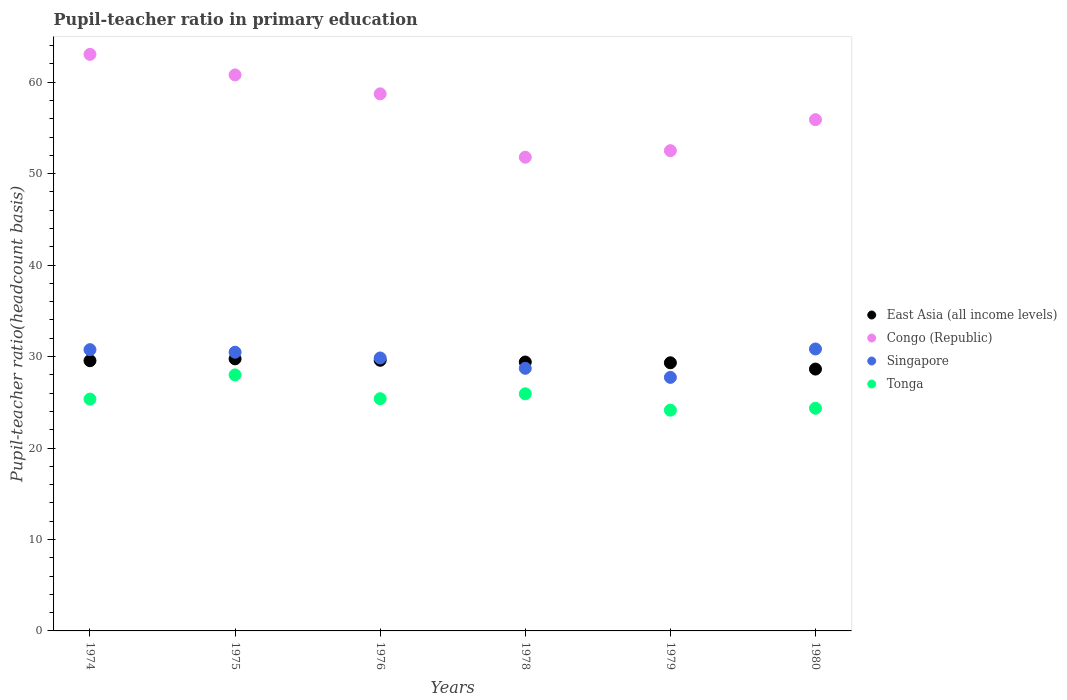How many different coloured dotlines are there?
Your response must be concise. 4. Is the number of dotlines equal to the number of legend labels?
Provide a succinct answer. Yes. What is the pupil-teacher ratio in primary education in Congo (Republic) in 1978?
Provide a short and direct response. 51.8. Across all years, what is the maximum pupil-teacher ratio in primary education in Tonga?
Keep it short and to the point. 27.99. Across all years, what is the minimum pupil-teacher ratio in primary education in Singapore?
Your answer should be very brief. 27.72. In which year was the pupil-teacher ratio in primary education in Tonga maximum?
Provide a short and direct response. 1975. In which year was the pupil-teacher ratio in primary education in Congo (Republic) minimum?
Your response must be concise. 1978. What is the total pupil-teacher ratio in primary education in Congo (Republic) in the graph?
Offer a very short reply. 342.76. What is the difference between the pupil-teacher ratio in primary education in East Asia (all income levels) in 1974 and that in 1976?
Keep it short and to the point. -0.05. What is the difference between the pupil-teacher ratio in primary education in Tonga in 1978 and the pupil-teacher ratio in primary education in Congo (Republic) in 1976?
Your answer should be very brief. -32.8. What is the average pupil-teacher ratio in primary education in Tonga per year?
Ensure brevity in your answer.  25.52. In the year 1975, what is the difference between the pupil-teacher ratio in primary education in East Asia (all income levels) and pupil-teacher ratio in primary education in Singapore?
Provide a short and direct response. -0.73. In how many years, is the pupil-teacher ratio in primary education in Congo (Republic) greater than 12?
Keep it short and to the point. 6. What is the ratio of the pupil-teacher ratio in primary education in East Asia (all income levels) in 1975 to that in 1979?
Make the answer very short. 1.01. Is the pupil-teacher ratio in primary education in Tonga in 1975 less than that in 1980?
Ensure brevity in your answer.  No. What is the difference between the highest and the second highest pupil-teacher ratio in primary education in Tonga?
Your answer should be very brief. 2.07. What is the difference between the highest and the lowest pupil-teacher ratio in primary education in Singapore?
Your response must be concise. 3.11. In how many years, is the pupil-teacher ratio in primary education in East Asia (all income levels) greater than the average pupil-teacher ratio in primary education in East Asia (all income levels) taken over all years?
Keep it short and to the point. 4. Is the sum of the pupil-teacher ratio in primary education in East Asia (all income levels) in 1975 and 1978 greater than the maximum pupil-teacher ratio in primary education in Singapore across all years?
Provide a short and direct response. Yes. Is it the case that in every year, the sum of the pupil-teacher ratio in primary education in East Asia (all income levels) and pupil-teacher ratio in primary education in Singapore  is greater than the sum of pupil-teacher ratio in primary education in Congo (Republic) and pupil-teacher ratio in primary education in Tonga?
Provide a succinct answer. No. Does the pupil-teacher ratio in primary education in Congo (Republic) monotonically increase over the years?
Provide a short and direct response. No. Is the pupil-teacher ratio in primary education in Congo (Republic) strictly greater than the pupil-teacher ratio in primary education in Tonga over the years?
Provide a short and direct response. Yes. What is the difference between two consecutive major ticks on the Y-axis?
Offer a very short reply. 10. Are the values on the major ticks of Y-axis written in scientific E-notation?
Make the answer very short. No. Does the graph contain any zero values?
Provide a short and direct response. No. Does the graph contain grids?
Your answer should be very brief. No. Where does the legend appear in the graph?
Give a very brief answer. Center right. How are the legend labels stacked?
Provide a succinct answer. Vertical. What is the title of the graph?
Offer a terse response. Pupil-teacher ratio in primary education. Does "Hong Kong" appear as one of the legend labels in the graph?
Make the answer very short. No. What is the label or title of the X-axis?
Your answer should be very brief. Years. What is the label or title of the Y-axis?
Ensure brevity in your answer.  Pupil-teacher ratio(headcount basis). What is the Pupil-teacher ratio(headcount basis) in East Asia (all income levels) in 1974?
Provide a succinct answer. 29.54. What is the Pupil-teacher ratio(headcount basis) of Congo (Republic) in 1974?
Offer a very short reply. 63.04. What is the Pupil-teacher ratio(headcount basis) in Singapore in 1974?
Provide a short and direct response. 30.75. What is the Pupil-teacher ratio(headcount basis) in Tonga in 1974?
Your response must be concise. 25.35. What is the Pupil-teacher ratio(headcount basis) in East Asia (all income levels) in 1975?
Make the answer very short. 29.75. What is the Pupil-teacher ratio(headcount basis) of Congo (Republic) in 1975?
Offer a very short reply. 60.79. What is the Pupil-teacher ratio(headcount basis) of Singapore in 1975?
Provide a succinct answer. 30.47. What is the Pupil-teacher ratio(headcount basis) in Tonga in 1975?
Keep it short and to the point. 27.99. What is the Pupil-teacher ratio(headcount basis) in East Asia (all income levels) in 1976?
Your response must be concise. 29.59. What is the Pupil-teacher ratio(headcount basis) in Congo (Republic) in 1976?
Your answer should be very brief. 58.72. What is the Pupil-teacher ratio(headcount basis) of Singapore in 1976?
Keep it short and to the point. 29.84. What is the Pupil-teacher ratio(headcount basis) of Tonga in 1976?
Provide a succinct answer. 25.39. What is the Pupil-teacher ratio(headcount basis) of East Asia (all income levels) in 1978?
Your answer should be very brief. 29.4. What is the Pupil-teacher ratio(headcount basis) of Congo (Republic) in 1978?
Ensure brevity in your answer.  51.8. What is the Pupil-teacher ratio(headcount basis) in Singapore in 1978?
Provide a short and direct response. 28.71. What is the Pupil-teacher ratio(headcount basis) in Tonga in 1978?
Provide a short and direct response. 25.93. What is the Pupil-teacher ratio(headcount basis) of East Asia (all income levels) in 1979?
Make the answer very short. 29.32. What is the Pupil-teacher ratio(headcount basis) in Congo (Republic) in 1979?
Offer a very short reply. 52.51. What is the Pupil-teacher ratio(headcount basis) of Singapore in 1979?
Offer a very short reply. 27.72. What is the Pupil-teacher ratio(headcount basis) of Tonga in 1979?
Provide a short and direct response. 24.14. What is the Pupil-teacher ratio(headcount basis) of East Asia (all income levels) in 1980?
Provide a succinct answer. 28.63. What is the Pupil-teacher ratio(headcount basis) of Congo (Republic) in 1980?
Your answer should be very brief. 55.9. What is the Pupil-teacher ratio(headcount basis) of Singapore in 1980?
Offer a terse response. 30.83. What is the Pupil-teacher ratio(headcount basis) in Tonga in 1980?
Give a very brief answer. 24.34. Across all years, what is the maximum Pupil-teacher ratio(headcount basis) of East Asia (all income levels)?
Your response must be concise. 29.75. Across all years, what is the maximum Pupil-teacher ratio(headcount basis) in Congo (Republic)?
Provide a short and direct response. 63.04. Across all years, what is the maximum Pupil-teacher ratio(headcount basis) of Singapore?
Keep it short and to the point. 30.83. Across all years, what is the maximum Pupil-teacher ratio(headcount basis) in Tonga?
Offer a terse response. 27.99. Across all years, what is the minimum Pupil-teacher ratio(headcount basis) of East Asia (all income levels)?
Provide a short and direct response. 28.63. Across all years, what is the minimum Pupil-teacher ratio(headcount basis) in Congo (Republic)?
Your answer should be very brief. 51.8. Across all years, what is the minimum Pupil-teacher ratio(headcount basis) in Singapore?
Ensure brevity in your answer.  27.72. Across all years, what is the minimum Pupil-teacher ratio(headcount basis) in Tonga?
Keep it short and to the point. 24.14. What is the total Pupil-teacher ratio(headcount basis) in East Asia (all income levels) in the graph?
Ensure brevity in your answer.  176.23. What is the total Pupil-teacher ratio(headcount basis) of Congo (Republic) in the graph?
Offer a very short reply. 342.76. What is the total Pupil-teacher ratio(headcount basis) in Singapore in the graph?
Provide a short and direct response. 178.33. What is the total Pupil-teacher ratio(headcount basis) in Tonga in the graph?
Give a very brief answer. 153.14. What is the difference between the Pupil-teacher ratio(headcount basis) in East Asia (all income levels) in 1974 and that in 1975?
Make the answer very short. -0.2. What is the difference between the Pupil-teacher ratio(headcount basis) in Congo (Republic) in 1974 and that in 1975?
Your answer should be compact. 2.25. What is the difference between the Pupil-teacher ratio(headcount basis) of Singapore in 1974 and that in 1975?
Provide a short and direct response. 0.28. What is the difference between the Pupil-teacher ratio(headcount basis) of Tonga in 1974 and that in 1975?
Your answer should be compact. -2.65. What is the difference between the Pupil-teacher ratio(headcount basis) in East Asia (all income levels) in 1974 and that in 1976?
Make the answer very short. -0.05. What is the difference between the Pupil-teacher ratio(headcount basis) in Congo (Republic) in 1974 and that in 1976?
Keep it short and to the point. 4.32. What is the difference between the Pupil-teacher ratio(headcount basis) of Singapore in 1974 and that in 1976?
Your answer should be compact. 0.91. What is the difference between the Pupil-teacher ratio(headcount basis) of Tonga in 1974 and that in 1976?
Provide a short and direct response. -0.04. What is the difference between the Pupil-teacher ratio(headcount basis) in East Asia (all income levels) in 1974 and that in 1978?
Provide a short and direct response. 0.14. What is the difference between the Pupil-teacher ratio(headcount basis) of Congo (Republic) in 1974 and that in 1978?
Give a very brief answer. 11.24. What is the difference between the Pupil-teacher ratio(headcount basis) of Singapore in 1974 and that in 1978?
Ensure brevity in your answer.  2.04. What is the difference between the Pupil-teacher ratio(headcount basis) in Tonga in 1974 and that in 1978?
Your answer should be compact. -0.58. What is the difference between the Pupil-teacher ratio(headcount basis) in East Asia (all income levels) in 1974 and that in 1979?
Give a very brief answer. 0.23. What is the difference between the Pupil-teacher ratio(headcount basis) of Congo (Republic) in 1974 and that in 1979?
Your response must be concise. 10.53. What is the difference between the Pupil-teacher ratio(headcount basis) in Singapore in 1974 and that in 1979?
Give a very brief answer. 3.03. What is the difference between the Pupil-teacher ratio(headcount basis) in Tonga in 1974 and that in 1979?
Provide a short and direct response. 1.21. What is the difference between the Pupil-teacher ratio(headcount basis) of East Asia (all income levels) in 1974 and that in 1980?
Your answer should be compact. 0.91. What is the difference between the Pupil-teacher ratio(headcount basis) of Congo (Republic) in 1974 and that in 1980?
Your answer should be compact. 7.14. What is the difference between the Pupil-teacher ratio(headcount basis) of Singapore in 1974 and that in 1980?
Ensure brevity in your answer.  -0.08. What is the difference between the Pupil-teacher ratio(headcount basis) in Tonga in 1974 and that in 1980?
Offer a terse response. 1. What is the difference between the Pupil-teacher ratio(headcount basis) of East Asia (all income levels) in 1975 and that in 1976?
Provide a succinct answer. 0.16. What is the difference between the Pupil-teacher ratio(headcount basis) in Congo (Republic) in 1975 and that in 1976?
Give a very brief answer. 2.07. What is the difference between the Pupil-teacher ratio(headcount basis) in Singapore in 1975 and that in 1976?
Your answer should be compact. 0.63. What is the difference between the Pupil-teacher ratio(headcount basis) of Tonga in 1975 and that in 1976?
Offer a terse response. 2.6. What is the difference between the Pupil-teacher ratio(headcount basis) of East Asia (all income levels) in 1975 and that in 1978?
Provide a succinct answer. 0.35. What is the difference between the Pupil-teacher ratio(headcount basis) in Congo (Republic) in 1975 and that in 1978?
Your response must be concise. 9. What is the difference between the Pupil-teacher ratio(headcount basis) in Singapore in 1975 and that in 1978?
Your answer should be compact. 1.76. What is the difference between the Pupil-teacher ratio(headcount basis) of Tonga in 1975 and that in 1978?
Your response must be concise. 2.07. What is the difference between the Pupil-teacher ratio(headcount basis) in East Asia (all income levels) in 1975 and that in 1979?
Provide a succinct answer. 0.43. What is the difference between the Pupil-teacher ratio(headcount basis) of Congo (Republic) in 1975 and that in 1979?
Give a very brief answer. 8.28. What is the difference between the Pupil-teacher ratio(headcount basis) of Singapore in 1975 and that in 1979?
Give a very brief answer. 2.75. What is the difference between the Pupil-teacher ratio(headcount basis) in Tonga in 1975 and that in 1979?
Offer a very short reply. 3.86. What is the difference between the Pupil-teacher ratio(headcount basis) of East Asia (all income levels) in 1975 and that in 1980?
Your response must be concise. 1.12. What is the difference between the Pupil-teacher ratio(headcount basis) of Congo (Republic) in 1975 and that in 1980?
Give a very brief answer. 4.9. What is the difference between the Pupil-teacher ratio(headcount basis) of Singapore in 1975 and that in 1980?
Your answer should be compact. -0.36. What is the difference between the Pupil-teacher ratio(headcount basis) of Tonga in 1975 and that in 1980?
Ensure brevity in your answer.  3.65. What is the difference between the Pupil-teacher ratio(headcount basis) of East Asia (all income levels) in 1976 and that in 1978?
Keep it short and to the point. 0.19. What is the difference between the Pupil-teacher ratio(headcount basis) in Congo (Republic) in 1976 and that in 1978?
Keep it short and to the point. 6.93. What is the difference between the Pupil-teacher ratio(headcount basis) in Singapore in 1976 and that in 1978?
Ensure brevity in your answer.  1.13. What is the difference between the Pupil-teacher ratio(headcount basis) of Tonga in 1976 and that in 1978?
Offer a very short reply. -0.54. What is the difference between the Pupil-teacher ratio(headcount basis) of East Asia (all income levels) in 1976 and that in 1979?
Make the answer very short. 0.27. What is the difference between the Pupil-teacher ratio(headcount basis) in Congo (Republic) in 1976 and that in 1979?
Ensure brevity in your answer.  6.21. What is the difference between the Pupil-teacher ratio(headcount basis) of Singapore in 1976 and that in 1979?
Provide a short and direct response. 2.12. What is the difference between the Pupil-teacher ratio(headcount basis) of Tonga in 1976 and that in 1979?
Your response must be concise. 1.25. What is the difference between the Pupil-teacher ratio(headcount basis) of East Asia (all income levels) in 1976 and that in 1980?
Offer a very short reply. 0.96. What is the difference between the Pupil-teacher ratio(headcount basis) of Congo (Republic) in 1976 and that in 1980?
Make the answer very short. 2.82. What is the difference between the Pupil-teacher ratio(headcount basis) in Singapore in 1976 and that in 1980?
Give a very brief answer. -0.98. What is the difference between the Pupil-teacher ratio(headcount basis) in Tonga in 1976 and that in 1980?
Give a very brief answer. 1.05. What is the difference between the Pupil-teacher ratio(headcount basis) of East Asia (all income levels) in 1978 and that in 1979?
Keep it short and to the point. 0.08. What is the difference between the Pupil-teacher ratio(headcount basis) in Congo (Republic) in 1978 and that in 1979?
Provide a short and direct response. -0.72. What is the difference between the Pupil-teacher ratio(headcount basis) of Singapore in 1978 and that in 1979?
Your answer should be compact. 0.99. What is the difference between the Pupil-teacher ratio(headcount basis) of Tonga in 1978 and that in 1979?
Provide a succinct answer. 1.79. What is the difference between the Pupil-teacher ratio(headcount basis) in East Asia (all income levels) in 1978 and that in 1980?
Make the answer very short. 0.77. What is the difference between the Pupil-teacher ratio(headcount basis) in Congo (Republic) in 1978 and that in 1980?
Your response must be concise. -4.1. What is the difference between the Pupil-teacher ratio(headcount basis) in Singapore in 1978 and that in 1980?
Give a very brief answer. -2.11. What is the difference between the Pupil-teacher ratio(headcount basis) of Tonga in 1978 and that in 1980?
Your answer should be compact. 1.58. What is the difference between the Pupil-teacher ratio(headcount basis) of East Asia (all income levels) in 1979 and that in 1980?
Make the answer very short. 0.69. What is the difference between the Pupil-teacher ratio(headcount basis) of Congo (Republic) in 1979 and that in 1980?
Make the answer very short. -3.39. What is the difference between the Pupil-teacher ratio(headcount basis) in Singapore in 1979 and that in 1980?
Ensure brevity in your answer.  -3.11. What is the difference between the Pupil-teacher ratio(headcount basis) in Tonga in 1979 and that in 1980?
Make the answer very short. -0.21. What is the difference between the Pupil-teacher ratio(headcount basis) of East Asia (all income levels) in 1974 and the Pupil-teacher ratio(headcount basis) of Congo (Republic) in 1975?
Your answer should be compact. -31.25. What is the difference between the Pupil-teacher ratio(headcount basis) in East Asia (all income levels) in 1974 and the Pupil-teacher ratio(headcount basis) in Singapore in 1975?
Make the answer very short. -0.93. What is the difference between the Pupil-teacher ratio(headcount basis) of East Asia (all income levels) in 1974 and the Pupil-teacher ratio(headcount basis) of Tonga in 1975?
Provide a succinct answer. 1.55. What is the difference between the Pupil-teacher ratio(headcount basis) in Congo (Republic) in 1974 and the Pupil-teacher ratio(headcount basis) in Singapore in 1975?
Make the answer very short. 32.57. What is the difference between the Pupil-teacher ratio(headcount basis) of Congo (Republic) in 1974 and the Pupil-teacher ratio(headcount basis) of Tonga in 1975?
Your answer should be very brief. 35.05. What is the difference between the Pupil-teacher ratio(headcount basis) in Singapore in 1974 and the Pupil-teacher ratio(headcount basis) in Tonga in 1975?
Give a very brief answer. 2.76. What is the difference between the Pupil-teacher ratio(headcount basis) in East Asia (all income levels) in 1974 and the Pupil-teacher ratio(headcount basis) in Congo (Republic) in 1976?
Make the answer very short. -29.18. What is the difference between the Pupil-teacher ratio(headcount basis) in East Asia (all income levels) in 1974 and the Pupil-teacher ratio(headcount basis) in Singapore in 1976?
Offer a very short reply. -0.3. What is the difference between the Pupil-teacher ratio(headcount basis) in East Asia (all income levels) in 1974 and the Pupil-teacher ratio(headcount basis) in Tonga in 1976?
Your answer should be very brief. 4.15. What is the difference between the Pupil-teacher ratio(headcount basis) in Congo (Republic) in 1974 and the Pupil-teacher ratio(headcount basis) in Singapore in 1976?
Your response must be concise. 33.2. What is the difference between the Pupil-teacher ratio(headcount basis) of Congo (Republic) in 1974 and the Pupil-teacher ratio(headcount basis) of Tonga in 1976?
Ensure brevity in your answer.  37.65. What is the difference between the Pupil-teacher ratio(headcount basis) of Singapore in 1974 and the Pupil-teacher ratio(headcount basis) of Tonga in 1976?
Offer a terse response. 5.36. What is the difference between the Pupil-teacher ratio(headcount basis) of East Asia (all income levels) in 1974 and the Pupil-teacher ratio(headcount basis) of Congo (Republic) in 1978?
Ensure brevity in your answer.  -22.25. What is the difference between the Pupil-teacher ratio(headcount basis) of East Asia (all income levels) in 1974 and the Pupil-teacher ratio(headcount basis) of Singapore in 1978?
Make the answer very short. 0.83. What is the difference between the Pupil-teacher ratio(headcount basis) in East Asia (all income levels) in 1974 and the Pupil-teacher ratio(headcount basis) in Tonga in 1978?
Provide a short and direct response. 3.62. What is the difference between the Pupil-teacher ratio(headcount basis) in Congo (Republic) in 1974 and the Pupil-teacher ratio(headcount basis) in Singapore in 1978?
Your answer should be very brief. 34.33. What is the difference between the Pupil-teacher ratio(headcount basis) of Congo (Republic) in 1974 and the Pupil-teacher ratio(headcount basis) of Tonga in 1978?
Keep it short and to the point. 37.11. What is the difference between the Pupil-teacher ratio(headcount basis) of Singapore in 1974 and the Pupil-teacher ratio(headcount basis) of Tonga in 1978?
Keep it short and to the point. 4.83. What is the difference between the Pupil-teacher ratio(headcount basis) in East Asia (all income levels) in 1974 and the Pupil-teacher ratio(headcount basis) in Congo (Republic) in 1979?
Keep it short and to the point. -22.97. What is the difference between the Pupil-teacher ratio(headcount basis) in East Asia (all income levels) in 1974 and the Pupil-teacher ratio(headcount basis) in Singapore in 1979?
Offer a terse response. 1.82. What is the difference between the Pupil-teacher ratio(headcount basis) of East Asia (all income levels) in 1974 and the Pupil-teacher ratio(headcount basis) of Tonga in 1979?
Provide a short and direct response. 5.41. What is the difference between the Pupil-teacher ratio(headcount basis) in Congo (Republic) in 1974 and the Pupil-teacher ratio(headcount basis) in Singapore in 1979?
Provide a succinct answer. 35.32. What is the difference between the Pupil-teacher ratio(headcount basis) of Congo (Republic) in 1974 and the Pupil-teacher ratio(headcount basis) of Tonga in 1979?
Offer a very short reply. 38.9. What is the difference between the Pupil-teacher ratio(headcount basis) of Singapore in 1974 and the Pupil-teacher ratio(headcount basis) of Tonga in 1979?
Offer a very short reply. 6.62. What is the difference between the Pupil-teacher ratio(headcount basis) in East Asia (all income levels) in 1974 and the Pupil-teacher ratio(headcount basis) in Congo (Republic) in 1980?
Your answer should be compact. -26.35. What is the difference between the Pupil-teacher ratio(headcount basis) of East Asia (all income levels) in 1974 and the Pupil-teacher ratio(headcount basis) of Singapore in 1980?
Provide a succinct answer. -1.28. What is the difference between the Pupil-teacher ratio(headcount basis) of East Asia (all income levels) in 1974 and the Pupil-teacher ratio(headcount basis) of Tonga in 1980?
Your response must be concise. 5.2. What is the difference between the Pupil-teacher ratio(headcount basis) in Congo (Republic) in 1974 and the Pupil-teacher ratio(headcount basis) in Singapore in 1980?
Give a very brief answer. 32.21. What is the difference between the Pupil-teacher ratio(headcount basis) in Congo (Republic) in 1974 and the Pupil-teacher ratio(headcount basis) in Tonga in 1980?
Your response must be concise. 38.7. What is the difference between the Pupil-teacher ratio(headcount basis) of Singapore in 1974 and the Pupil-teacher ratio(headcount basis) of Tonga in 1980?
Make the answer very short. 6.41. What is the difference between the Pupil-teacher ratio(headcount basis) in East Asia (all income levels) in 1975 and the Pupil-teacher ratio(headcount basis) in Congo (Republic) in 1976?
Provide a succinct answer. -28.98. What is the difference between the Pupil-teacher ratio(headcount basis) in East Asia (all income levels) in 1975 and the Pupil-teacher ratio(headcount basis) in Singapore in 1976?
Offer a terse response. -0.1. What is the difference between the Pupil-teacher ratio(headcount basis) in East Asia (all income levels) in 1975 and the Pupil-teacher ratio(headcount basis) in Tonga in 1976?
Offer a terse response. 4.36. What is the difference between the Pupil-teacher ratio(headcount basis) of Congo (Republic) in 1975 and the Pupil-teacher ratio(headcount basis) of Singapore in 1976?
Ensure brevity in your answer.  30.95. What is the difference between the Pupil-teacher ratio(headcount basis) in Congo (Republic) in 1975 and the Pupil-teacher ratio(headcount basis) in Tonga in 1976?
Offer a very short reply. 35.4. What is the difference between the Pupil-teacher ratio(headcount basis) in Singapore in 1975 and the Pupil-teacher ratio(headcount basis) in Tonga in 1976?
Provide a succinct answer. 5.08. What is the difference between the Pupil-teacher ratio(headcount basis) of East Asia (all income levels) in 1975 and the Pupil-teacher ratio(headcount basis) of Congo (Republic) in 1978?
Your answer should be very brief. -22.05. What is the difference between the Pupil-teacher ratio(headcount basis) of East Asia (all income levels) in 1975 and the Pupil-teacher ratio(headcount basis) of Singapore in 1978?
Your response must be concise. 1.03. What is the difference between the Pupil-teacher ratio(headcount basis) of East Asia (all income levels) in 1975 and the Pupil-teacher ratio(headcount basis) of Tonga in 1978?
Keep it short and to the point. 3.82. What is the difference between the Pupil-teacher ratio(headcount basis) in Congo (Republic) in 1975 and the Pupil-teacher ratio(headcount basis) in Singapore in 1978?
Keep it short and to the point. 32.08. What is the difference between the Pupil-teacher ratio(headcount basis) of Congo (Republic) in 1975 and the Pupil-teacher ratio(headcount basis) of Tonga in 1978?
Make the answer very short. 34.87. What is the difference between the Pupil-teacher ratio(headcount basis) of Singapore in 1975 and the Pupil-teacher ratio(headcount basis) of Tonga in 1978?
Your response must be concise. 4.55. What is the difference between the Pupil-teacher ratio(headcount basis) in East Asia (all income levels) in 1975 and the Pupil-teacher ratio(headcount basis) in Congo (Republic) in 1979?
Ensure brevity in your answer.  -22.76. What is the difference between the Pupil-teacher ratio(headcount basis) of East Asia (all income levels) in 1975 and the Pupil-teacher ratio(headcount basis) of Singapore in 1979?
Make the answer very short. 2.02. What is the difference between the Pupil-teacher ratio(headcount basis) in East Asia (all income levels) in 1975 and the Pupil-teacher ratio(headcount basis) in Tonga in 1979?
Your response must be concise. 5.61. What is the difference between the Pupil-teacher ratio(headcount basis) of Congo (Republic) in 1975 and the Pupil-teacher ratio(headcount basis) of Singapore in 1979?
Your answer should be compact. 33.07. What is the difference between the Pupil-teacher ratio(headcount basis) of Congo (Republic) in 1975 and the Pupil-teacher ratio(headcount basis) of Tonga in 1979?
Your answer should be very brief. 36.66. What is the difference between the Pupil-teacher ratio(headcount basis) of Singapore in 1975 and the Pupil-teacher ratio(headcount basis) of Tonga in 1979?
Give a very brief answer. 6.34. What is the difference between the Pupil-teacher ratio(headcount basis) in East Asia (all income levels) in 1975 and the Pupil-teacher ratio(headcount basis) in Congo (Republic) in 1980?
Your answer should be compact. -26.15. What is the difference between the Pupil-teacher ratio(headcount basis) of East Asia (all income levels) in 1975 and the Pupil-teacher ratio(headcount basis) of Singapore in 1980?
Ensure brevity in your answer.  -1.08. What is the difference between the Pupil-teacher ratio(headcount basis) in East Asia (all income levels) in 1975 and the Pupil-teacher ratio(headcount basis) in Tonga in 1980?
Keep it short and to the point. 5.4. What is the difference between the Pupil-teacher ratio(headcount basis) of Congo (Republic) in 1975 and the Pupil-teacher ratio(headcount basis) of Singapore in 1980?
Keep it short and to the point. 29.97. What is the difference between the Pupil-teacher ratio(headcount basis) of Congo (Republic) in 1975 and the Pupil-teacher ratio(headcount basis) of Tonga in 1980?
Your answer should be compact. 36.45. What is the difference between the Pupil-teacher ratio(headcount basis) of Singapore in 1975 and the Pupil-teacher ratio(headcount basis) of Tonga in 1980?
Keep it short and to the point. 6.13. What is the difference between the Pupil-teacher ratio(headcount basis) of East Asia (all income levels) in 1976 and the Pupil-teacher ratio(headcount basis) of Congo (Republic) in 1978?
Ensure brevity in your answer.  -22.2. What is the difference between the Pupil-teacher ratio(headcount basis) in East Asia (all income levels) in 1976 and the Pupil-teacher ratio(headcount basis) in Singapore in 1978?
Make the answer very short. 0.88. What is the difference between the Pupil-teacher ratio(headcount basis) in East Asia (all income levels) in 1976 and the Pupil-teacher ratio(headcount basis) in Tonga in 1978?
Your response must be concise. 3.67. What is the difference between the Pupil-teacher ratio(headcount basis) in Congo (Republic) in 1976 and the Pupil-teacher ratio(headcount basis) in Singapore in 1978?
Your answer should be compact. 30.01. What is the difference between the Pupil-teacher ratio(headcount basis) of Congo (Republic) in 1976 and the Pupil-teacher ratio(headcount basis) of Tonga in 1978?
Make the answer very short. 32.8. What is the difference between the Pupil-teacher ratio(headcount basis) of Singapore in 1976 and the Pupil-teacher ratio(headcount basis) of Tonga in 1978?
Your response must be concise. 3.92. What is the difference between the Pupil-teacher ratio(headcount basis) of East Asia (all income levels) in 1976 and the Pupil-teacher ratio(headcount basis) of Congo (Republic) in 1979?
Your answer should be very brief. -22.92. What is the difference between the Pupil-teacher ratio(headcount basis) of East Asia (all income levels) in 1976 and the Pupil-teacher ratio(headcount basis) of Singapore in 1979?
Your response must be concise. 1.87. What is the difference between the Pupil-teacher ratio(headcount basis) of East Asia (all income levels) in 1976 and the Pupil-teacher ratio(headcount basis) of Tonga in 1979?
Provide a short and direct response. 5.45. What is the difference between the Pupil-teacher ratio(headcount basis) in Congo (Republic) in 1976 and the Pupil-teacher ratio(headcount basis) in Singapore in 1979?
Ensure brevity in your answer.  31. What is the difference between the Pupil-teacher ratio(headcount basis) of Congo (Republic) in 1976 and the Pupil-teacher ratio(headcount basis) of Tonga in 1979?
Offer a terse response. 34.59. What is the difference between the Pupil-teacher ratio(headcount basis) of Singapore in 1976 and the Pupil-teacher ratio(headcount basis) of Tonga in 1979?
Your answer should be very brief. 5.71. What is the difference between the Pupil-teacher ratio(headcount basis) in East Asia (all income levels) in 1976 and the Pupil-teacher ratio(headcount basis) in Congo (Republic) in 1980?
Make the answer very short. -26.31. What is the difference between the Pupil-teacher ratio(headcount basis) in East Asia (all income levels) in 1976 and the Pupil-teacher ratio(headcount basis) in Singapore in 1980?
Your answer should be very brief. -1.24. What is the difference between the Pupil-teacher ratio(headcount basis) in East Asia (all income levels) in 1976 and the Pupil-teacher ratio(headcount basis) in Tonga in 1980?
Your response must be concise. 5.25. What is the difference between the Pupil-teacher ratio(headcount basis) in Congo (Republic) in 1976 and the Pupil-teacher ratio(headcount basis) in Singapore in 1980?
Your response must be concise. 27.9. What is the difference between the Pupil-teacher ratio(headcount basis) in Congo (Republic) in 1976 and the Pupil-teacher ratio(headcount basis) in Tonga in 1980?
Provide a short and direct response. 34.38. What is the difference between the Pupil-teacher ratio(headcount basis) of Singapore in 1976 and the Pupil-teacher ratio(headcount basis) of Tonga in 1980?
Keep it short and to the point. 5.5. What is the difference between the Pupil-teacher ratio(headcount basis) in East Asia (all income levels) in 1978 and the Pupil-teacher ratio(headcount basis) in Congo (Republic) in 1979?
Keep it short and to the point. -23.11. What is the difference between the Pupil-teacher ratio(headcount basis) in East Asia (all income levels) in 1978 and the Pupil-teacher ratio(headcount basis) in Singapore in 1979?
Provide a succinct answer. 1.68. What is the difference between the Pupil-teacher ratio(headcount basis) in East Asia (all income levels) in 1978 and the Pupil-teacher ratio(headcount basis) in Tonga in 1979?
Provide a succinct answer. 5.26. What is the difference between the Pupil-teacher ratio(headcount basis) in Congo (Republic) in 1978 and the Pupil-teacher ratio(headcount basis) in Singapore in 1979?
Ensure brevity in your answer.  24.07. What is the difference between the Pupil-teacher ratio(headcount basis) in Congo (Republic) in 1978 and the Pupil-teacher ratio(headcount basis) in Tonga in 1979?
Ensure brevity in your answer.  27.66. What is the difference between the Pupil-teacher ratio(headcount basis) of Singapore in 1978 and the Pupil-teacher ratio(headcount basis) of Tonga in 1979?
Offer a very short reply. 4.58. What is the difference between the Pupil-teacher ratio(headcount basis) in East Asia (all income levels) in 1978 and the Pupil-teacher ratio(headcount basis) in Congo (Republic) in 1980?
Ensure brevity in your answer.  -26.5. What is the difference between the Pupil-teacher ratio(headcount basis) of East Asia (all income levels) in 1978 and the Pupil-teacher ratio(headcount basis) of Singapore in 1980?
Provide a short and direct response. -1.43. What is the difference between the Pupil-teacher ratio(headcount basis) in East Asia (all income levels) in 1978 and the Pupil-teacher ratio(headcount basis) in Tonga in 1980?
Keep it short and to the point. 5.06. What is the difference between the Pupil-teacher ratio(headcount basis) in Congo (Republic) in 1978 and the Pupil-teacher ratio(headcount basis) in Singapore in 1980?
Give a very brief answer. 20.97. What is the difference between the Pupil-teacher ratio(headcount basis) in Congo (Republic) in 1978 and the Pupil-teacher ratio(headcount basis) in Tonga in 1980?
Your answer should be compact. 27.45. What is the difference between the Pupil-teacher ratio(headcount basis) in Singapore in 1978 and the Pupil-teacher ratio(headcount basis) in Tonga in 1980?
Your response must be concise. 4.37. What is the difference between the Pupil-teacher ratio(headcount basis) of East Asia (all income levels) in 1979 and the Pupil-teacher ratio(headcount basis) of Congo (Republic) in 1980?
Keep it short and to the point. -26.58. What is the difference between the Pupil-teacher ratio(headcount basis) of East Asia (all income levels) in 1979 and the Pupil-teacher ratio(headcount basis) of Singapore in 1980?
Make the answer very short. -1.51. What is the difference between the Pupil-teacher ratio(headcount basis) of East Asia (all income levels) in 1979 and the Pupil-teacher ratio(headcount basis) of Tonga in 1980?
Provide a succinct answer. 4.97. What is the difference between the Pupil-teacher ratio(headcount basis) of Congo (Republic) in 1979 and the Pupil-teacher ratio(headcount basis) of Singapore in 1980?
Offer a very short reply. 21.68. What is the difference between the Pupil-teacher ratio(headcount basis) of Congo (Republic) in 1979 and the Pupil-teacher ratio(headcount basis) of Tonga in 1980?
Give a very brief answer. 28.17. What is the difference between the Pupil-teacher ratio(headcount basis) of Singapore in 1979 and the Pupil-teacher ratio(headcount basis) of Tonga in 1980?
Your answer should be compact. 3.38. What is the average Pupil-teacher ratio(headcount basis) in East Asia (all income levels) per year?
Your answer should be compact. 29.37. What is the average Pupil-teacher ratio(headcount basis) of Congo (Republic) per year?
Ensure brevity in your answer.  57.13. What is the average Pupil-teacher ratio(headcount basis) of Singapore per year?
Provide a short and direct response. 29.72. What is the average Pupil-teacher ratio(headcount basis) in Tonga per year?
Make the answer very short. 25.52. In the year 1974, what is the difference between the Pupil-teacher ratio(headcount basis) of East Asia (all income levels) and Pupil-teacher ratio(headcount basis) of Congo (Republic)?
Your answer should be compact. -33.5. In the year 1974, what is the difference between the Pupil-teacher ratio(headcount basis) of East Asia (all income levels) and Pupil-teacher ratio(headcount basis) of Singapore?
Offer a terse response. -1.21. In the year 1974, what is the difference between the Pupil-teacher ratio(headcount basis) of East Asia (all income levels) and Pupil-teacher ratio(headcount basis) of Tonga?
Keep it short and to the point. 4.2. In the year 1974, what is the difference between the Pupil-teacher ratio(headcount basis) of Congo (Republic) and Pupil-teacher ratio(headcount basis) of Singapore?
Ensure brevity in your answer.  32.29. In the year 1974, what is the difference between the Pupil-teacher ratio(headcount basis) of Congo (Republic) and Pupil-teacher ratio(headcount basis) of Tonga?
Provide a succinct answer. 37.69. In the year 1974, what is the difference between the Pupil-teacher ratio(headcount basis) of Singapore and Pupil-teacher ratio(headcount basis) of Tonga?
Provide a succinct answer. 5.41. In the year 1975, what is the difference between the Pupil-teacher ratio(headcount basis) in East Asia (all income levels) and Pupil-teacher ratio(headcount basis) in Congo (Republic)?
Your response must be concise. -31.05. In the year 1975, what is the difference between the Pupil-teacher ratio(headcount basis) in East Asia (all income levels) and Pupil-teacher ratio(headcount basis) in Singapore?
Your response must be concise. -0.73. In the year 1975, what is the difference between the Pupil-teacher ratio(headcount basis) in East Asia (all income levels) and Pupil-teacher ratio(headcount basis) in Tonga?
Your answer should be compact. 1.75. In the year 1975, what is the difference between the Pupil-teacher ratio(headcount basis) in Congo (Republic) and Pupil-teacher ratio(headcount basis) in Singapore?
Offer a terse response. 30.32. In the year 1975, what is the difference between the Pupil-teacher ratio(headcount basis) in Congo (Republic) and Pupil-teacher ratio(headcount basis) in Tonga?
Your response must be concise. 32.8. In the year 1975, what is the difference between the Pupil-teacher ratio(headcount basis) of Singapore and Pupil-teacher ratio(headcount basis) of Tonga?
Give a very brief answer. 2.48. In the year 1976, what is the difference between the Pupil-teacher ratio(headcount basis) of East Asia (all income levels) and Pupil-teacher ratio(headcount basis) of Congo (Republic)?
Your answer should be compact. -29.13. In the year 1976, what is the difference between the Pupil-teacher ratio(headcount basis) of East Asia (all income levels) and Pupil-teacher ratio(headcount basis) of Singapore?
Provide a short and direct response. -0.25. In the year 1976, what is the difference between the Pupil-teacher ratio(headcount basis) of East Asia (all income levels) and Pupil-teacher ratio(headcount basis) of Tonga?
Keep it short and to the point. 4.2. In the year 1976, what is the difference between the Pupil-teacher ratio(headcount basis) of Congo (Republic) and Pupil-teacher ratio(headcount basis) of Singapore?
Ensure brevity in your answer.  28.88. In the year 1976, what is the difference between the Pupil-teacher ratio(headcount basis) of Congo (Republic) and Pupil-teacher ratio(headcount basis) of Tonga?
Offer a very short reply. 33.33. In the year 1976, what is the difference between the Pupil-teacher ratio(headcount basis) of Singapore and Pupil-teacher ratio(headcount basis) of Tonga?
Your response must be concise. 4.45. In the year 1978, what is the difference between the Pupil-teacher ratio(headcount basis) in East Asia (all income levels) and Pupil-teacher ratio(headcount basis) in Congo (Republic)?
Your answer should be very brief. -22.4. In the year 1978, what is the difference between the Pupil-teacher ratio(headcount basis) in East Asia (all income levels) and Pupil-teacher ratio(headcount basis) in Singapore?
Your answer should be compact. 0.69. In the year 1978, what is the difference between the Pupil-teacher ratio(headcount basis) in East Asia (all income levels) and Pupil-teacher ratio(headcount basis) in Tonga?
Provide a short and direct response. 3.47. In the year 1978, what is the difference between the Pupil-teacher ratio(headcount basis) in Congo (Republic) and Pupil-teacher ratio(headcount basis) in Singapore?
Make the answer very short. 23.08. In the year 1978, what is the difference between the Pupil-teacher ratio(headcount basis) of Congo (Republic) and Pupil-teacher ratio(headcount basis) of Tonga?
Ensure brevity in your answer.  25.87. In the year 1978, what is the difference between the Pupil-teacher ratio(headcount basis) of Singapore and Pupil-teacher ratio(headcount basis) of Tonga?
Your answer should be very brief. 2.79. In the year 1979, what is the difference between the Pupil-teacher ratio(headcount basis) in East Asia (all income levels) and Pupil-teacher ratio(headcount basis) in Congo (Republic)?
Make the answer very short. -23.19. In the year 1979, what is the difference between the Pupil-teacher ratio(headcount basis) in East Asia (all income levels) and Pupil-teacher ratio(headcount basis) in Singapore?
Your answer should be very brief. 1.6. In the year 1979, what is the difference between the Pupil-teacher ratio(headcount basis) of East Asia (all income levels) and Pupil-teacher ratio(headcount basis) of Tonga?
Provide a short and direct response. 5.18. In the year 1979, what is the difference between the Pupil-teacher ratio(headcount basis) of Congo (Republic) and Pupil-teacher ratio(headcount basis) of Singapore?
Offer a terse response. 24.79. In the year 1979, what is the difference between the Pupil-teacher ratio(headcount basis) in Congo (Republic) and Pupil-teacher ratio(headcount basis) in Tonga?
Give a very brief answer. 28.37. In the year 1979, what is the difference between the Pupil-teacher ratio(headcount basis) of Singapore and Pupil-teacher ratio(headcount basis) of Tonga?
Your answer should be very brief. 3.59. In the year 1980, what is the difference between the Pupil-teacher ratio(headcount basis) in East Asia (all income levels) and Pupil-teacher ratio(headcount basis) in Congo (Republic)?
Offer a very short reply. -27.27. In the year 1980, what is the difference between the Pupil-teacher ratio(headcount basis) in East Asia (all income levels) and Pupil-teacher ratio(headcount basis) in Singapore?
Make the answer very short. -2.2. In the year 1980, what is the difference between the Pupil-teacher ratio(headcount basis) of East Asia (all income levels) and Pupil-teacher ratio(headcount basis) of Tonga?
Offer a very short reply. 4.29. In the year 1980, what is the difference between the Pupil-teacher ratio(headcount basis) in Congo (Republic) and Pupil-teacher ratio(headcount basis) in Singapore?
Your answer should be very brief. 25.07. In the year 1980, what is the difference between the Pupil-teacher ratio(headcount basis) in Congo (Republic) and Pupil-teacher ratio(headcount basis) in Tonga?
Make the answer very short. 31.56. In the year 1980, what is the difference between the Pupil-teacher ratio(headcount basis) in Singapore and Pupil-teacher ratio(headcount basis) in Tonga?
Provide a succinct answer. 6.48. What is the ratio of the Pupil-teacher ratio(headcount basis) in East Asia (all income levels) in 1974 to that in 1975?
Your response must be concise. 0.99. What is the ratio of the Pupil-teacher ratio(headcount basis) in Congo (Republic) in 1974 to that in 1975?
Provide a succinct answer. 1.04. What is the ratio of the Pupil-teacher ratio(headcount basis) in Singapore in 1974 to that in 1975?
Your answer should be compact. 1.01. What is the ratio of the Pupil-teacher ratio(headcount basis) in Tonga in 1974 to that in 1975?
Provide a succinct answer. 0.91. What is the ratio of the Pupil-teacher ratio(headcount basis) of East Asia (all income levels) in 1974 to that in 1976?
Keep it short and to the point. 1. What is the ratio of the Pupil-teacher ratio(headcount basis) of Congo (Republic) in 1974 to that in 1976?
Your answer should be very brief. 1.07. What is the ratio of the Pupil-teacher ratio(headcount basis) of Singapore in 1974 to that in 1976?
Give a very brief answer. 1.03. What is the ratio of the Pupil-teacher ratio(headcount basis) of Congo (Republic) in 1974 to that in 1978?
Give a very brief answer. 1.22. What is the ratio of the Pupil-teacher ratio(headcount basis) of Singapore in 1974 to that in 1978?
Give a very brief answer. 1.07. What is the ratio of the Pupil-teacher ratio(headcount basis) of Tonga in 1974 to that in 1978?
Your response must be concise. 0.98. What is the ratio of the Pupil-teacher ratio(headcount basis) in East Asia (all income levels) in 1974 to that in 1979?
Offer a very short reply. 1.01. What is the ratio of the Pupil-teacher ratio(headcount basis) in Congo (Republic) in 1974 to that in 1979?
Your response must be concise. 1.2. What is the ratio of the Pupil-teacher ratio(headcount basis) in Singapore in 1974 to that in 1979?
Give a very brief answer. 1.11. What is the ratio of the Pupil-teacher ratio(headcount basis) of Tonga in 1974 to that in 1979?
Keep it short and to the point. 1.05. What is the ratio of the Pupil-teacher ratio(headcount basis) in East Asia (all income levels) in 1974 to that in 1980?
Ensure brevity in your answer.  1.03. What is the ratio of the Pupil-teacher ratio(headcount basis) of Congo (Republic) in 1974 to that in 1980?
Give a very brief answer. 1.13. What is the ratio of the Pupil-teacher ratio(headcount basis) in Singapore in 1974 to that in 1980?
Your answer should be very brief. 1. What is the ratio of the Pupil-teacher ratio(headcount basis) in Tonga in 1974 to that in 1980?
Offer a terse response. 1.04. What is the ratio of the Pupil-teacher ratio(headcount basis) in Congo (Republic) in 1975 to that in 1976?
Your answer should be compact. 1.04. What is the ratio of the Pupil-teacher ratio(headcount basis) of Tonga in 1975 to that in 1976?
Your response must be concise. 1.1. What is the ratio of the Pupil-teacher ratio(headcount basis) of East Asia (all income levels) in 1975 to that in 1978?
Make the answer very short. 1.01. What is the ratio of the Pupil-teacher ratio(headcount basis) of Congo (Republic) in 1975 to that in 1978?
Your answer should be compact. 1.17. What is the ratio of the Pupil-teacher ratio(headcount basis) in Singapore in 1975 to that in 1978?
Ensure brevity in your answer.  1.06. What is the ratio of the Pupil-teacher ratio(headcount basis) of Tonga in 1975 to that in 1978?
Keep it short and to the point. 1.08. What is the ratio of the Pupil-teacher ratio(headcount basis) in East Asia (all income levels) in 1975 to that in 1979?
Offer a terse response. 1.01. What is the ratio of the Pupil-teacher ratio(headcount basis) in Congo (Republic) in 1975 to that in 1979?
Ensure brevity in your answer.  1.16. What is the ratio of the Pupil-teacher ratio(headcount basis) of Singapore in 1975 to that in 1979?
Provide a succinct answer. 1.1. What is the ratio of the Pupil-teacher ratio(headcount basis) in Tonga in 1975 to that in 1979?
Provide a short and direct response. 1.16. What is the ratio of the Pupil-teacher ratio(headcount basis) of East Asia (all income levels) in 1975 to that in 1980?
Make the answer very short. 1.04. What is the ratio of the Pupil-teacher ratio(headcount basis) in Congo (Republic) in 1975 to that in 1980?
Make the answer very short. 1.09. What is the ratio of the Pupil-teacher ratio(headcount basis) of Singapore in 1975 to that in 1980?
Your answer should be compact. 0.99. What is the ratio of the Pupil-teacher ratio(headcount basis) in Tonga in 1975 to that in 1980?
Your response must be concise. 1.15. What is the ratio of the Pupil-teacher ratio(headcount basis) in Congo (Republic) in 1976 to that in 1978?
Your answer should be very brief. 1.13. What is the ratio of the Pupil-teacher ratio(headcount basis) in Singapore in 1976 to that in 1978?
Ensure brevity in your answer.  1.04. What is the ratio of the Pupil-teacher ratio(headcount basis) of Tonga in 1976 to that in 1978?
Ensure brevity in your answer.  0.98. What is the ratio of the Pupil-teacher ratio(headcount basis) of East Asia (all income levels) in 1976 to that in 1979?
Make the answer very short. 1.01. What is the ratio of the Pupil-teacher ratio(headcount basis) of Congo (Republic) in 1976 to that in 1979?
Provide a short and direct response. 1.12. What is the ratio of the Pupil-teacher ratio(headcount basis) of Singapore in 1976 to that in 1979?
Offer a terse response. 1.08. What is the ratio of the Pupil-teacher ratio(headcount basis) in Tonga in 1976 to that in 1979?
Your response must be concise. 1.05. What is the ratio of the Pupil-teacher ratio(headcount basis) of East Asia (all income levels) in 1976 to that in 1980?
Ensure brevity in your answer.  1.03. What is the ratio of the Pupil-teacher ratio(headcount basis) of Congo (Republic) in 1976 to that in 1980?
Ensure brevity in your answer.  1.05. What is the ratio of the Pupil-teacher ratio(headcount basis) in Singapore in 1976 to that in 1980?
Offer a terse response. 0.97. What is the ratio of the Pupil-teacher ratio(headcount basis) in Tonga in 1976 to that in 1980?
Offer a terse response. 1.04. What is the ratio of the Pupil-teacher ratio(headcount basis) in Congo (Republic) in 1978 to that in 1979?
Provide a short and direct response. 0.99. What is the ratio of the Pupil-teacher ratio(headcount basis) in Singapore in 1978 to that in 1979?
Your answer should be very brief. 1.04. What is the ratio of the Pupil-teacher ratio(headcount basis) of Tonga in 1978 to that in 1979?
Provide a succinct answer. 1.07. What is the ratio of the Pupil-teacher ratio(headcount basis) in East Asia (all income levels) in 1978 to that in 1980?
Keep it short and to the point. 1.03. What is the ratio of the Pupil-teacher ratio(headcount basis) of Congo (Republic) in 1978 to that in 1980?
Provide a succinct answer. 0.93. What is the ratio of the Pupil-teacher ratio(headcount basis) of Singapore in 1978 to that in 1980?
Provide a succinct answer. 0.93. What is the ratio of the Pupil-teacher ratio(headcount basis) of Tonga in 1978 to that in 1980?
Provide a succinct answer. 1.06. What is the ratio of the Pupil-teacher ratio(headcount basis) of East Asia (all income levels) in 1979 to that in 1980?
Provide a short and direct response. 1.02. What is the ratio of the Pupil-teacher ratio(headcount basis) of Congo (Republic) in 1979 to that in 1980?
Make the answer very short. 0.94. What is the ratio of the Pupil-teacher ratio(headcount basis) in Singapore in 1979 to that in 1980?
Give a very brief answer. 0.9. What is the ratio of the Pupil-teacher ratio(headcount basis) of Tonga in 1979 to that in 1980?
Keep it short and to the point. 0.99. What is the difference between the highest and the second highest Pupil-teacher ratio(headcount basis) of East Asia (all income levels)?
Make the answer very short. 0.16. What is the difference between the highest and the second highest Pupil-teacher ratio(headcount basis) in Congo (Republic)?
Keep it short and to the point. 2.25. What is the difference between the highest and the second highest Pupil-teacher ratio(headcount basis) in Singapore?
Your response must be concise. 0.08. What is the difference between the highest and the second highest Pupil-teacher ratio(headcount basis) in Tonga?
Give a very brief answer. 2.07. What is the difference between the highest and the lowest Pupil-teacher ratio(headcount basis) of East Asia (all income levels)?
Provide a short and direct response. 1.12. What is the difference between the highest and the lowest Pupil-teacher ratio(headcount basis) of Congo (Republic)?
Make the answer very short. 11.24. What is the difference between the highest and the lowest Pupil-teacher ratio(headcount basis) in Singapore?
Offer a very short reply. 3.11. What is the difference between the highest and the lowest Pupil-teacher ratio(headcount basis) of Tonga?
Offer a terse response. 3.86. 